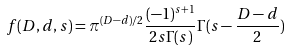Convert formula to latex. <formula><loc_0><loc_0><loc_500><loc_500>f ( D , d , s ) = \pi ^ { ( D - d ) / 2 } \frac { ( - 1 ) ^ { s + 1 } } { 2 s \Gamma ( s ) } \Gamma ( s - \frac { D - d } { 2 } )</formula> 